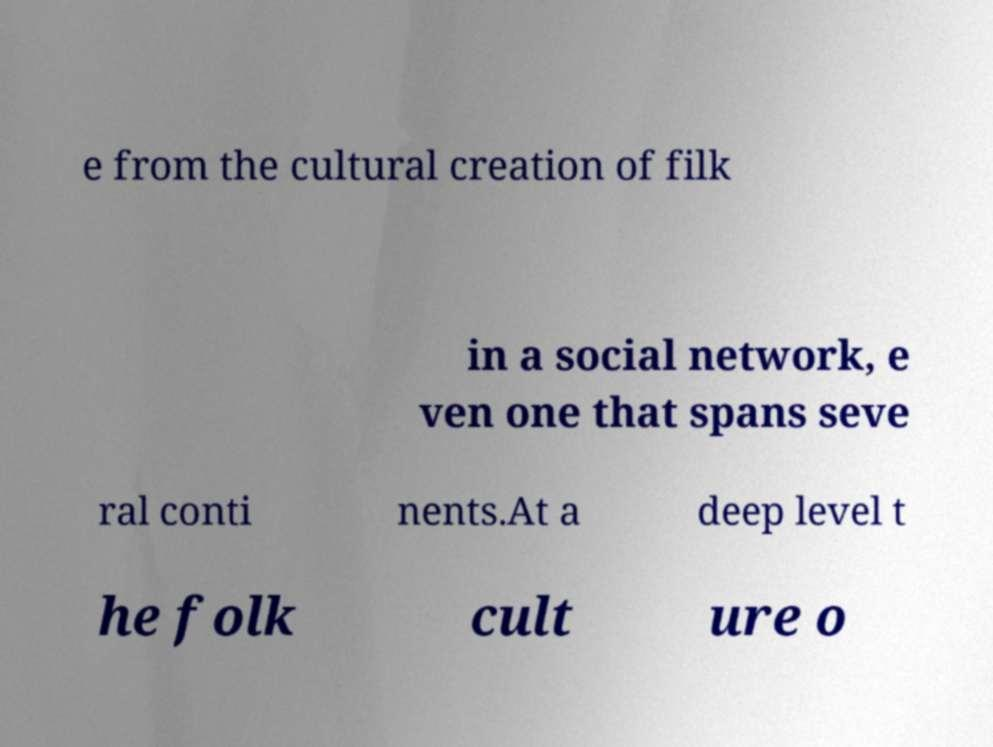I need the written content from this picture converted into text. Can you do that? e from the cultural creation of filk in a social network, e ven one that spans seve ral conti nents.At a deep level t he folk cult ure o 